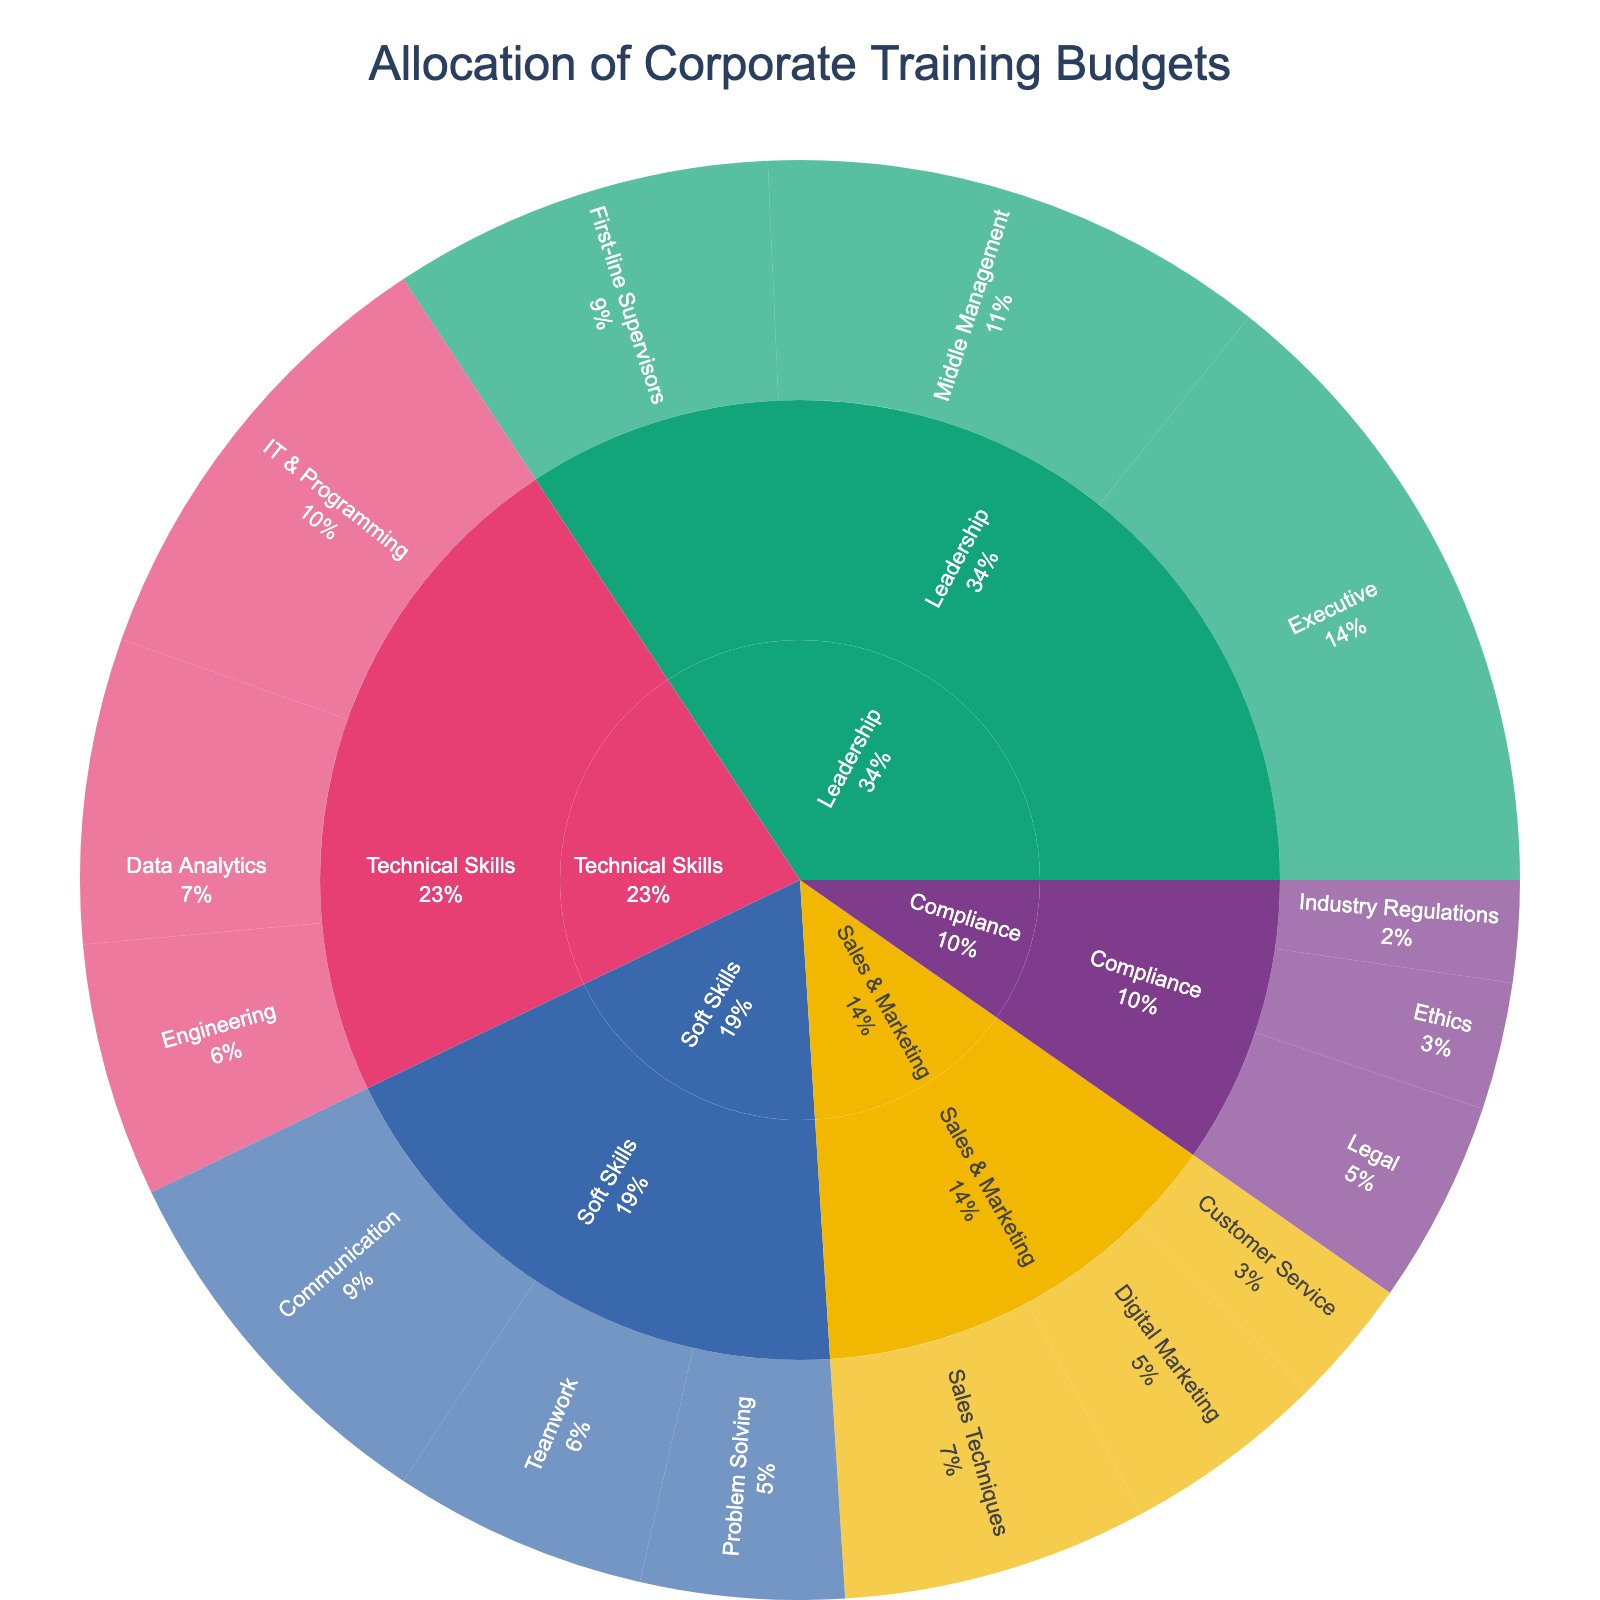What is the title of the figure? The title of the figure is located at the top and centrally aligned. It provides a summary of what the figure represents.
Answer: Allocation of Corporate Training Budgets Which skill development area has the highest budget allocation? Observe the segment with the largest area and the highest percentage in the sunburst plot.
Answer: Leadership What is the total budget allocation across all categories? Sum up the values from all subcategories: 25 (Leadership) + 20 + 15 + 18 (Technical Skills) + 12 + 10 + 15 (Soft Skills) + 10 + 8 + 8 (Compliance) + 5 + 4 + 12 (Sales & Marketing) + 8 + 5 = 180
Answer: 180 Which subcategory under Leadership has the highest budget? Identify the subcategory within the Leadership category with the largest segment.
Answer: Executive Compare the budget allocations between Technical Skills and Sales & Marketing. Which one has more funding, and by how much? Calculate the sum of values for Technical Skills and compare it with the sum of values for Sales & Marketing. Technical Skills: 18 + 12 + 10 = 40. Sales & Marketing: 12 + 8 + 5 = 25. The difference between them is 40 - 25 = 15.
Answer: Technical Skills, by 15 What percentage of the total budget is allocated to Compliance? Find the sum of values in the Compliance category: 8 + 5 + 4 = 17. Then divide this by the total budget (180) and multiply by 100 to get the percentage: (17 / 180) * 100 = 9.44%.
Answer: 9.44% Which skill development area under Technical Skills has the least budget? Identify the subcategory within the Technical Skills category with the smallest segment.
Answer: Engineering What is the average budget allocation for subcategories within Soft Skills? Calculate the sum of values for Soft Skills and divide by the number of subcategories: (15 + 10 + 8) / 3 = 11.
Answer: 11 Compare the budget allocation for Data Analytics and Customer Service. Which one has a higher budget and by how much? Directly compare values for Data Analytics (12) and Customer Service (5). Subtract the smaller value from the larger value: 12 - 5 = 7.
Answer: Data Analytics, by 7 